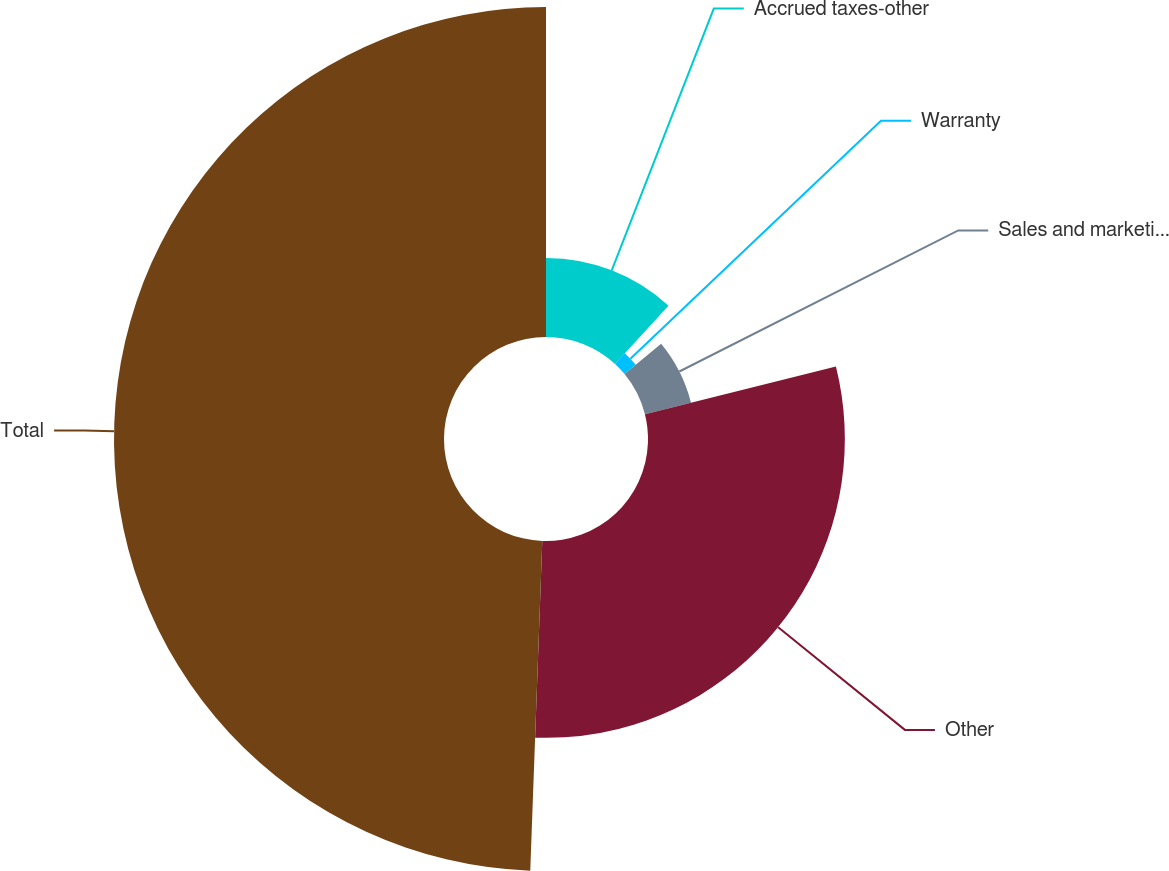Convert chart to OTSL. <chart><loc_0><loc_0><loc_500><loc_500><pie_chart><fcel>Accrued taxes-other<fcel>Warranty<fcel>Sales and marketing programs<fcel>Other<fcel>Total<nl><fcel>11.83%<fcel>2.16%<fcel>7.11%<fcel>29.48%<fcel>49.42%<nl></chart> 